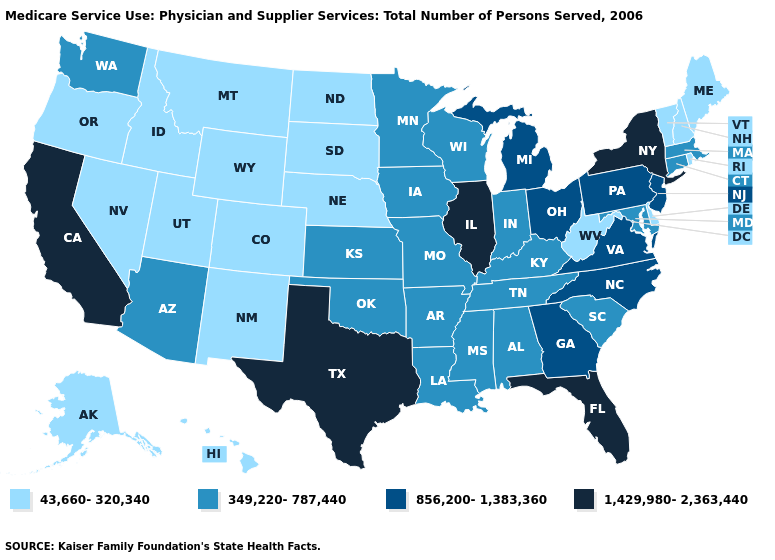Name the states that have a value in the range 856,200-1,383,360?
Give a very brief answer. Georgia, Michigan, New Jersey, North Carolina, Ohio, Pennsylvania, Virginia. Name the states that have a value in the range 1,429,980-2,363,440?
Short answer required. California, Florida, Illinois, New York, Texas. Does the map have missing data?
Quick response, please. No. What is the highest value in the MidWest ?
Answer briefly. 1,429,980-2,363,440. What is the value of Washington?
Write a very short answer. 349,220-787,440. What is the value of Alabama?
Answer briefly. 349,220-787,440. Name the states that have a value in the range 349,220-787,440?
Be succinct. Alabama, Arizona, Arkansas, Connecticut, Indiana, Iowa, Kansas, Kentucky, Louisiana, Maryland, Massachusetts, Minnesota, Mississippi, Missouri, Oklahoma, South Carolina, Tennessee, Washington, Wisconsin. Name the states that have a value in the range 349,220-787,440?
Answer briefly. Alabama, Arizona, Arkansas, Connecticut, Indiana, Iowa, Kansas, Kentucky, Louisiana, Maryland, Massachusetts, Minnesota, Mississippi, Missouri, Oklahoma, South Carolina, Tennessee, Washington, Wisconsin. Does Texas have the highest value in the USA?
Quick response, please. Yes. Which states have the highest value in the USA?
Keep it brief. California, Florida, Illinois, New York, Texas. Among the states that border Mississippi , which have the lowest value?
Keep it brief. Alabama, Arkansas, Louisiana, Tennessee. Which states have the lowest value in the USA?
Give a very brief answer. Alaska, Colorado, Delaware, Hawaii, Idaho, Maine, Montana, Nebraska, Nevada, New Hampshire, New Mexico, North Dakota, Oregon, Rhode Island, South Dakota, Utah, Vermont, West Virginia, Wyoming. What is the value of Minnesota?
Keep it brief. 349,220-787,440. Does Minnesota have the same value as Wyoming?
Give a very brief answer. No. Among the states that border North Dakota , which have the lowest value?
Be succinct. Montana, South Dakota. 